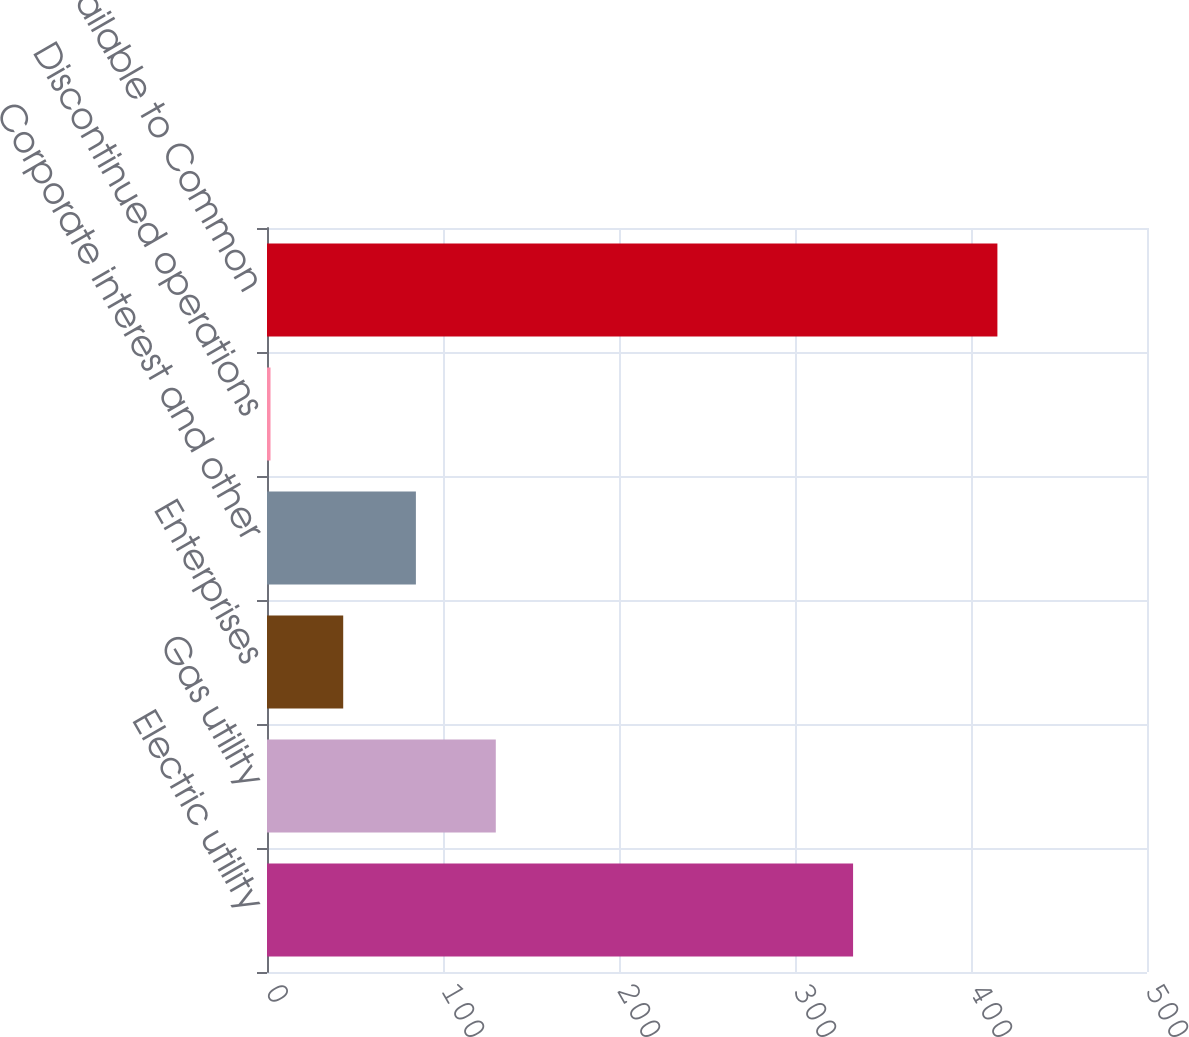Convert chart. <chart><loc_0><loc_0><loc_500><loc_500><bar_chart><fcel>Electric utility<fcel>Gas utility<fcel>Enterprises<fcel>Corporate interest and other<fcel>Discontinued operations<fcel>Net Income Available to Common<nl><fcel>333<fcel>130<fcel>43.3<fcel>84.6<fcel>2<fcel>415<nl></chart> 